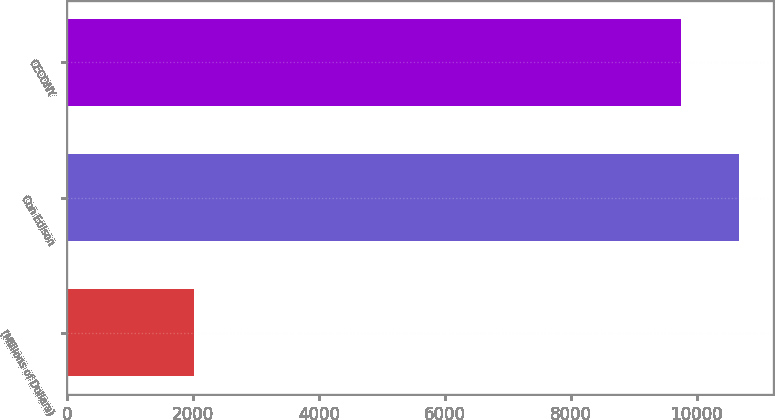Convert chart to OTSL. <chart><loc_0><loc_0><loc_500><loc_500><bar_chart><fcel>(Millions of Dollars)<fcel>Con Edison<fcel>CECONY<nl><fcel>2011<fcel>10673<fcel>9745<nl></chart> 